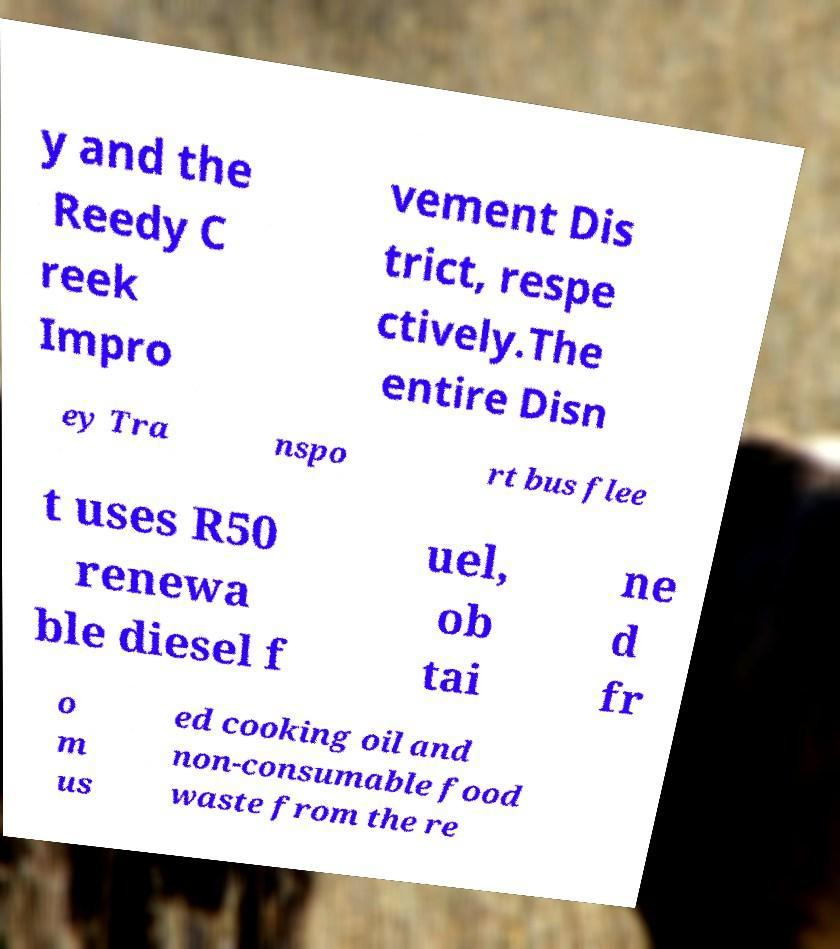Please read and relay the text visible in this image. What does it say? y and the Reedy C reek Impro vement Dis trict, respe ctively.The entire Disn ey Tra nspo rt bus flee t uses R50 renewa ble diesel f uel, ob tai ne d fr o m us ed cooking oil and non-consumable food waste from the re 